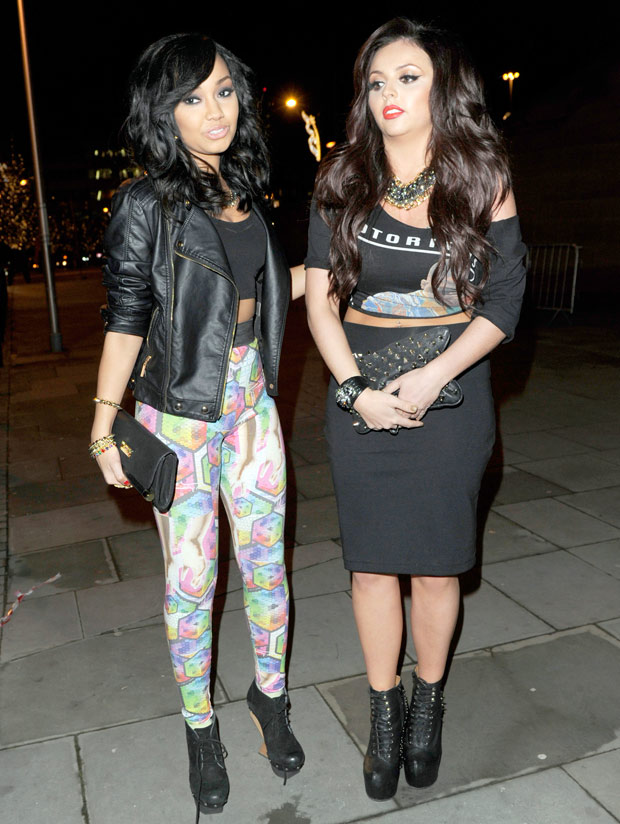Considering the lighting and background, where might this photo have been taken? The photo appears to have been taken in an urban outdoor setting at night. The ambient artificial lighting and the paved walkway suggest it is in a well-maintained public area, possibly a pedestrian street or plaza. The metal barrier indicates a space designed for controlled pedestrian movement. In the background, a tree and lit buildings or streets are visible, hinting at proximity to a park or recreational area within the city. The absence of other people or traffic implies a more secluded section or a private event near a nightlife venue. 